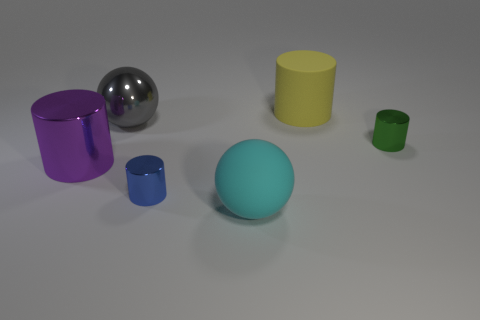How many objects are large objects that are on the left side of the large gray sphere or shiny cylinders right of the shiny ball?
Offer a very short reply. 3. Does the green object have the same material as the large thing that is left of the big gray sphere?
Give a very brief answer. Yes. What number of other objects are the same shape as the blue object?
Provide a succinct answer. 3. What material is the tiny cylinder on the left side of the small cylinder on the right side of the tiny metallic thing that is in front of the tiny green shiny cylinder?
Provide a succinct answer. Metal. Are there the same number of cyan matte balls behind the big rubber sphere and cyan metallic balls?
Your answer should be very brief. Yes. Does the tiny cylinder in front of the green object have the same material as the big sphere in front of the purple metal cylinder?
Your answer should be compact. No. There is a shiny object right of the cyan matte sphere; is it the same shape as the large matte thing that is behind the large cyan matte thing?
Provide a succinct answer. Yes. Is the number of yellow cylinders in front of the big yellow matte cylinder less than the number of big cyan objects?
Keep it short and to the point. Yes. What size is the rubber object behind the large cyan rubber object?
Your answer should be compact. Large. What is the shape of the large matte object in front of the large cylinder that is on the left side of the matte object in front of the big metallic ball?
Your answer should be very brief. Sphere. 